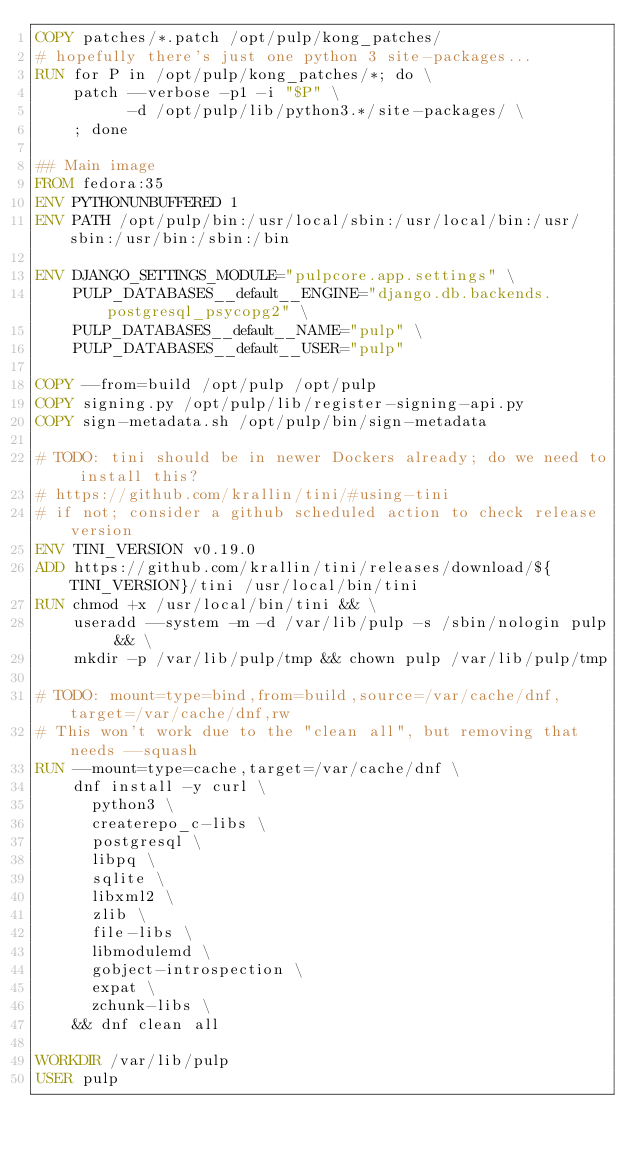<code> <loc_0><loc_0><loc_500><loc_500><_Dockerfile_>COPY patches/*.patch /opt/pulp/kong_patches/
# hopefully there's just one python 3 site-packages...
RUN for P in /opt/pulp/kong_patches/*; do \
    patch --verbose -p1 -i "$P" \
          -d /opt/pulp/lib/python3.*/site-packages/ \
    ; done

## Main image
FROM fedora:35
ENV PYTHONUNBUFFERED 1
ENV PATH /opt/pulp/bin:/usr/local/sbin:/usr/local/bin:/usr/sbin:/usr/bin:/sbin:/bin

ENV DJANGO_SETTINGS_MODULE="pulpcore.app.settings" \
    PULP_DATABASES__default__ENGINE="django.db.backends.postgresql_psycopg2" \
    PULP_DATABASES__default__NAME="pulp" \
    PULP_DATABASES__default__USER="pulp"

COPY --from=build /opt/pulp /opt/pulp
COPY signing.py /opt/pulp/lib/register-signing-api.py
COPY sign-metadata.sh /opt/pulp/bin/sign-metadata

# TODO: tini should be in newer Dockers already; do we need to install this?
# https://github.com/krallin/tini/#using-tini
# if not; consider a github scheduled action to check release version
ENV TINI_VERSION v0.19.0
ADD https://github.com/krallin/tini/releases/download/${TINI_VERSION}/tini /usr/local/bin/tini
RUN chmod +x /usr/local/bin/tini && \
    useradd --system -m -d /var/lib/pulp -s /sbin/nologin pulp && \
    mkdir -p /var/lib/pulp/tmp && chown pulp /var/lib/pulp/tmp

# TODO: mount=type=bind,from=build,source=/var/cache/dnf,target=/var/cache/dnf,rw
# This won't work due to the "clean all", but removing that needs --squash
RUN --mount=type=cache,target=/var/cache/dnf \
    dnf install -y curl \
      python3 \
      createrepo_c-libs \
      postgresql \
      libpq \
      sqlite \
      libxml2 \
      zlib \
      file-libs \
      libmodulemd \
      gobject-introspection \
      expat \
      zchunk-libs \
    && dnf clean all

WORKDIR /var/lib/pulp
USER pulp
</code> 